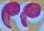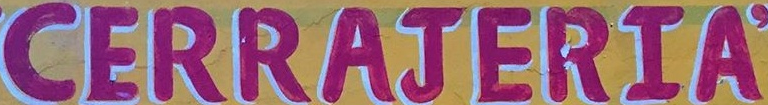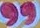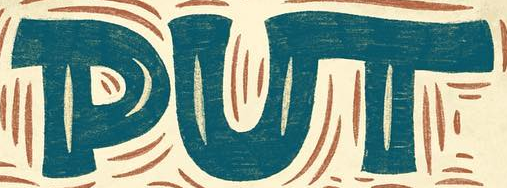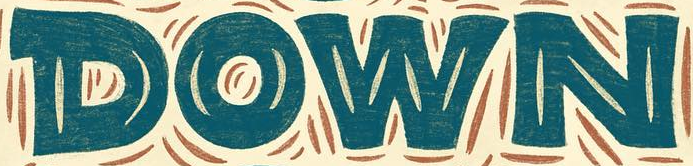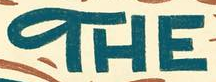Read the text from these images in sequence, separated by a semicolon. "; CERRAJERIA; "; PUT; DOWN; THE 